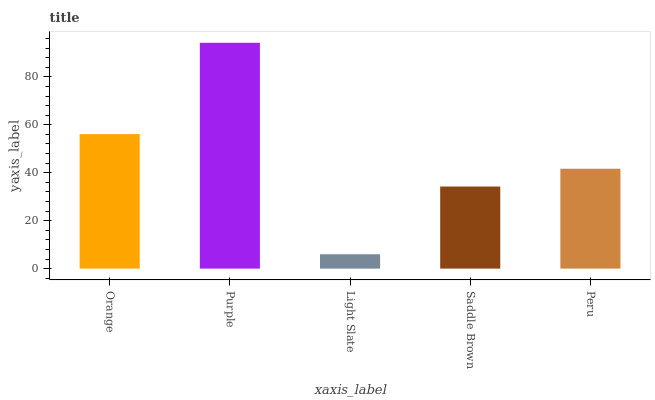Is Light Slate the minimum?
Answer yes or no. Yes. Is Purple the maximum?
Answer yes or no. Yes. Is Purple the minimum?
Answer yes or no. No. Is Light Slate the maximum?
Answer yes or no. No. Is Purple greater than Light Slate?
Answer yes or no. Yes. Is Light Slate less than Purple?
Answer yes or no. Yes. Is Light Slate greater than Purple?
Answer yes or no. No. Is Purple less than Light Slate?
Answer yes or no. No. Is Peru the high median?
Answer yes or no. Yes. Is Peru the low median?
Answer yes or no. Yes. Is Light Slate the high median?
Answer yes or no. No. Is Purple the low median?
Answer yes or no. No. 